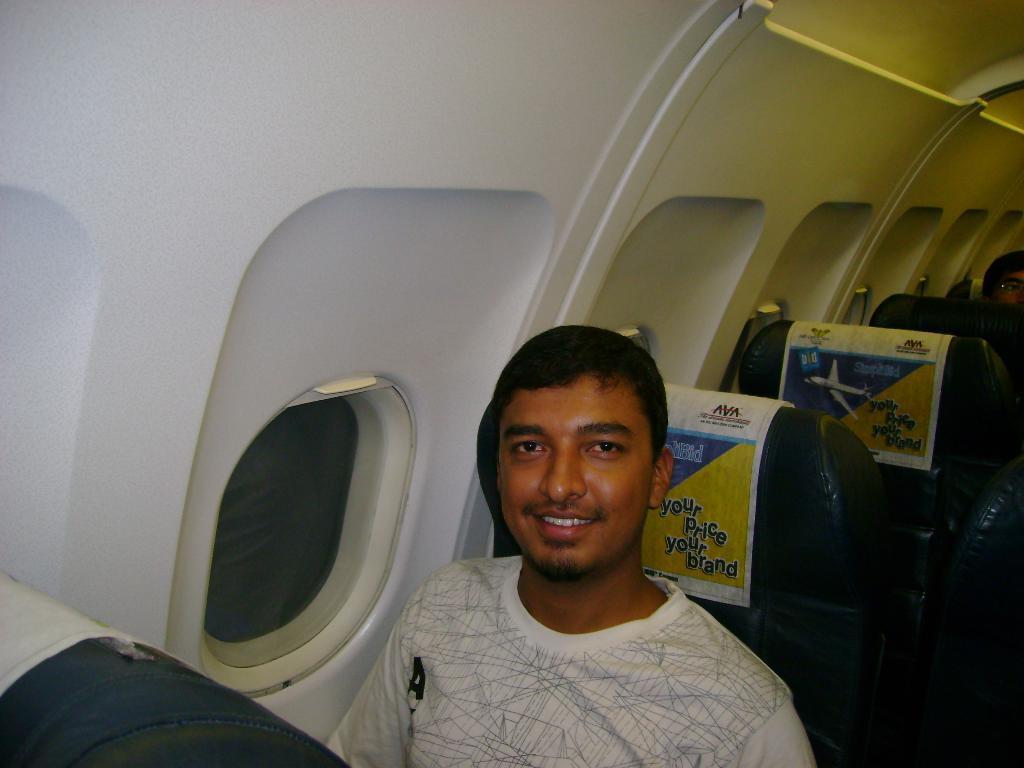Can you describe this image briefly? This image is taken inside of an airplane, where we can see a man sitting on a seat and in the background, there are few seats. 